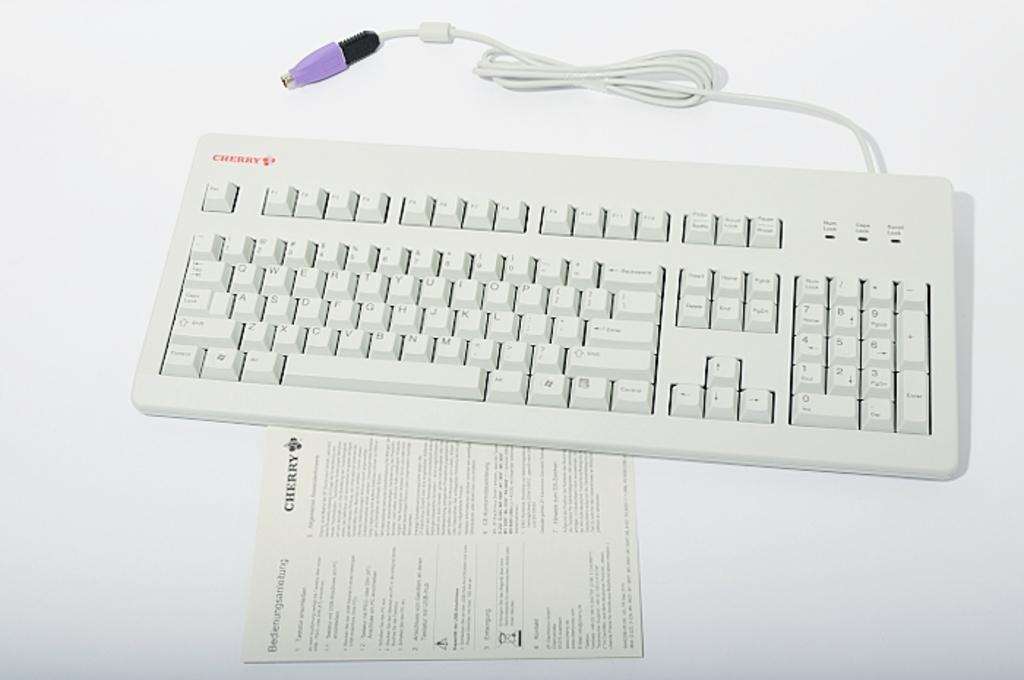<image>
Give a short and clear explanation of the subsequent image. A Cherry keyboard that has a purple adapter with an instruction manual 